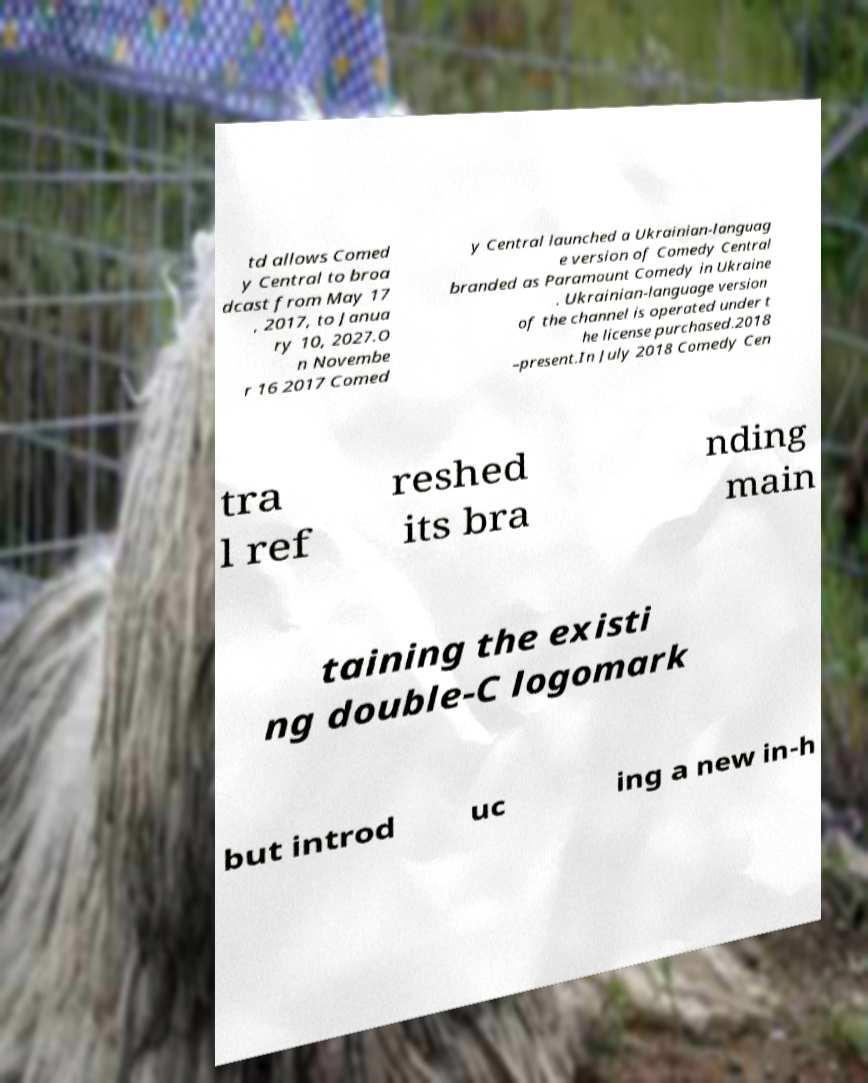What messages or text are displayed in this image? I need them in a readable, typed format. td allows Comed y Central to broa dcast from May 17 , 2017, to Janua ry 10, 2027.O n Novembe r 16 2017 Comed y Central launched a Ukrainian-languag e version of Comedy Central branded as Paramount Comedy in Ukraine . Ukrainian-language version of the channel is operated under t he license purchased.2018 –present.In July 2018 Comedy Cen tra l ref reshed its bra nding main taining the existi ng double-C logomark but introd uc ing a new in-h 